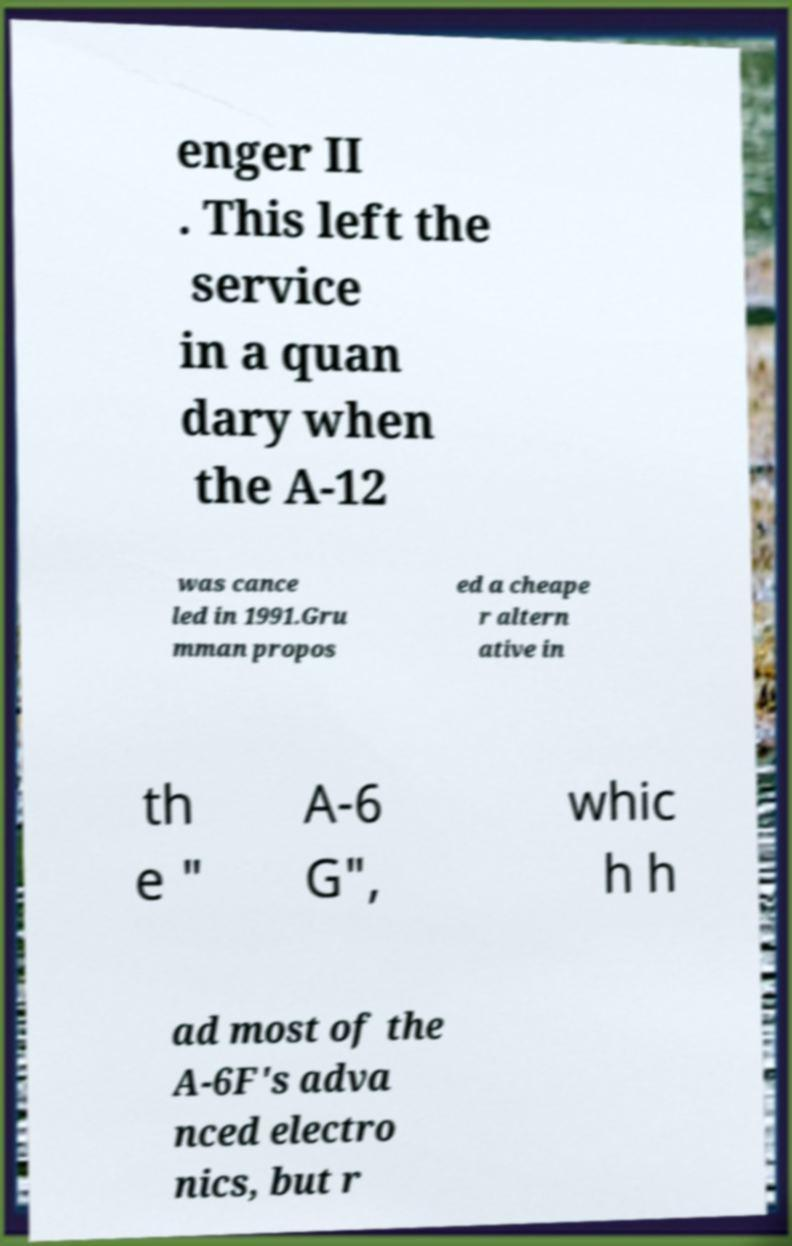Could you assist in decoding the text presented in this image and type it out clearly? enger II . This left the service in a quan dary when the A-12 was cance led in 1991.Gru mman propos ed a cheape r altern ative in th e " A-6 G", whic h h ad most of the A-6F's adva nced electro nics, but r 